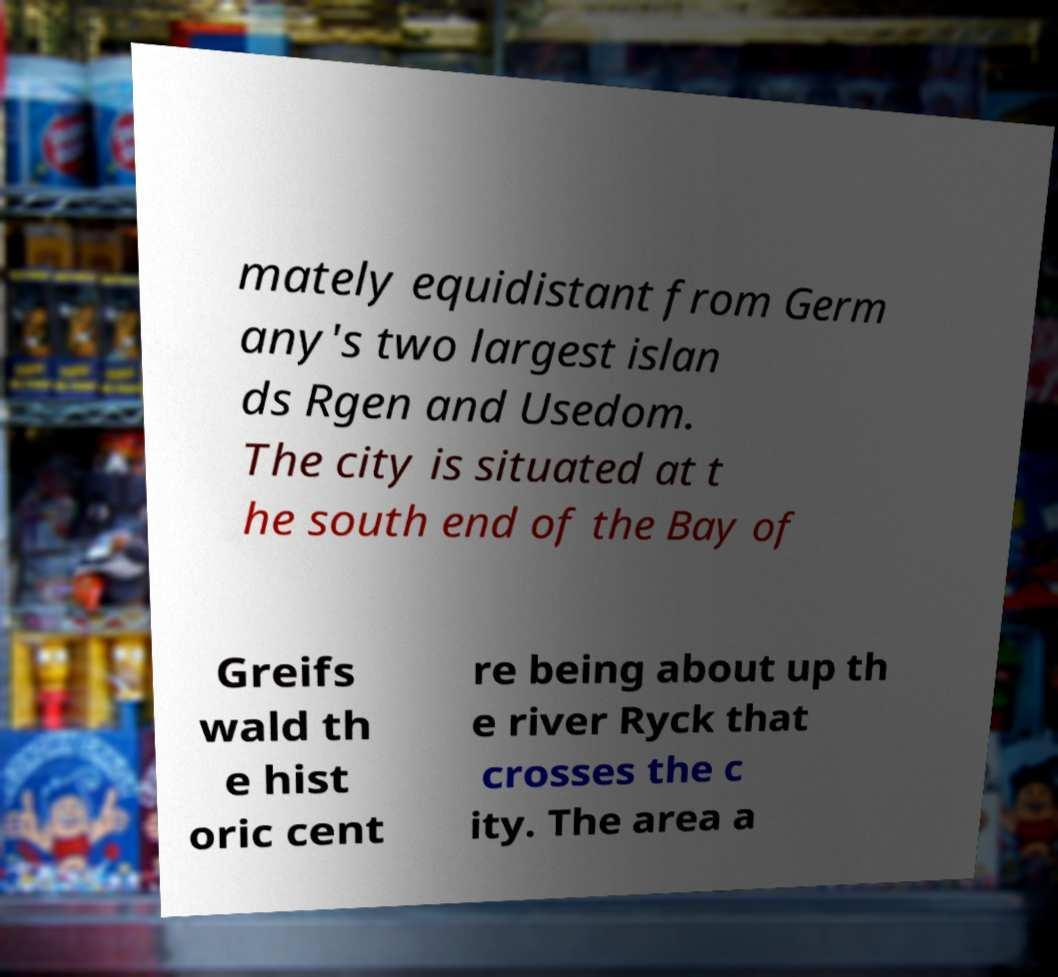What messages or text are displayed in this image? I need them in a readable, typed format. mately equidistant from Germ any's two largest islan ds Rgen and Usedom. The city is situated at t he south end of the Bay of Greifs wald th e hist oric cent re being about up th e river Ryck that crosses the c ity. The area a 